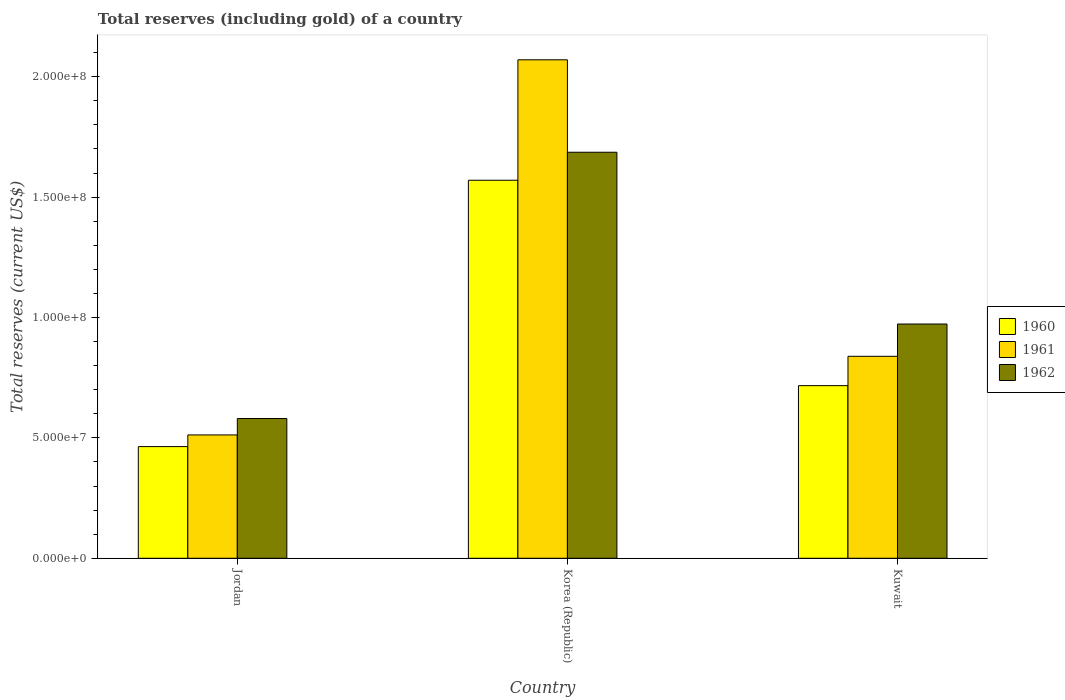How many different coloured bars are there?
Offer a terse response. 3. Are the number of bars per tick equal to the number of legend labels?
Your answer should be compact. Yes. How many bars are there on the 3rd tick from the left?
Offer a terse response. 3. What is the label of the 1st group of bars from the left?
Give a very brief answer. Jordan. What is the total reserves (including gold) in 1962 in Kuwait?
Your answer should be very brief. 9.73e+07. Across all countries, what is the maximum total reserves (including gold) in 1960?
Keep it short and to the point. 1.57e+08. Across all countries, what is the minimum total reserves (including gold) in 1962?
Your answer should be compact. 5.80e+07. In which country was the total reserves (including gold) in 1961 maximum?
Provide a short and direct response. Korea (Republic). In which country was the total reserves (including gold) in 1960 minimum?
Make the answer very short. Jordan. What is the total total reserves (including gold) in 1962 in the graph?
Your answer should be compact. 3.24e+08. What is the difference between the total reserves (including gold) in 1962 in Jordan and that in Korea (Republic)?
Offer a very short reply. -1.11e+08. What is the difference between the total reserves (including gold) in 1961 in Kuwait and the total reserves (including gold) in 1960 in Jordan?
Make the answer very short. 3.75e+07. What is the average total reserves (including gold) in 1962 per country?
Your answer should be very brief. 1.08e+08. What is the difference between the total reserves (including gold) of/in 1962 and total reserves (including gold) of/in 1961 in Korea (Republic)?
Your answer should be very brief. -3.84e+07. What is the ratio of the total reserves (including gold) in 1962 in Korea (Republic) to that in Kuwait?
Ensure brevity in your answer.  1.73. Is the difference between the total reserves (including gold) in 1962 in Jordan and Korea (Republic) greater than the difference between the total reserves (including gold) in 1961 in Jordan and Korea (Republic)?
Provide a short and direct response. Yes. What is the difference between the highest and the second highest total reserves (including gold) in 1961?
Your answer should be compact. -1.23e+08. What is the difference between the highest and the lowest total reserves (including gold) in 1961?
Make the answer very short. 1.56e+08. In how many countries, is the total reserves (including gold) in 1962 greater than the average total reserves (including gold) in 1962 taken over all countries?
Provide a succinct answer. 1. How many bars are there?
Provide a succinct answer. 9. What is the difference between two consecutive major ticks on the Y-axis?
Your response must be concise. 5.00e+07. Are the values on the major ticks of Y-axis written in scientific E-notation?
Keep it short and to the point. Yes. Does the graph contain any zero values?
Your response must be concise. No. Where does the legend appear in the graph?
Offer a terse response. Center right. How many legend labels are there?
Offer a terse response. 3. What is the title of the graph?
Ensure brevity in your answer.  Total reserves (including gold) of a country. Does "1989" appear as one of the legend labels in the graph?
Offer a terse response. No. What is the label or title of the Y-axis?
Keep it short and to the point. Total reserves (current US$). What is the Total reserves (current US$) of 1960 in Jordan?
Ensure brevity in your answer.  4.64e+07. What is the Total reserves (current US$) of 1961 in Jordan?
Provide a succinct answer. 5.12e+07. What is the Total reserves (current US$) of 1962 in Jordan?
Ensure brevity in your answer.  5.80e+07. What is the Total reserves (current US$) in 1960 in Korea (Republic)?
Offer a very short reply. 1.57e+08. What is the Total reserves (current US$) of 1961 in Korea (Republic)?
Your answer should be very brief. 2.07e+08. What is the Total reserves (current US$) in 1962 in Korea (Republic)?
Your response must be concise. 1.69e+08. What is the Total reserves (current US$) of 1960 in Kuwait?
Give a very brief answer. 7.17e+07. What is the Total reserves (current US$) in 1961 in Kuwait?
Ensure brevity in your answer.  8.39e+07. What is the Total reserves (current US$) of 1962 in Kuwait?
Give a very brief answer. 9.73e+07. Across all countries, what is the maximum Total reserves (current US$) in 1960?
Offer a terse response. 1.57e+08. Across all countries, what is the maximum Total reserves (current US$) of 1961?
Your answer should be very brief. 2.07e+08. Across all countries, what is the maximum Total reserves (current US$) in 1962?
Give a very brief answer. 1.69e+08. Across all countries, what is the minimum Total reserves (current US$) of 1960?
Make the answer very short. 4.64e+07. Across all countries, what is the minimum Total reserves (current US$) in 1961?
Your answer should be compact. 5.12e+07. Across all countries, what is the minimum Total reserves (current US$) of 1962?
Offer a very short reply. 5.80e+07. What is the total Total reserves (current US$) in 1960 in the graph?
Provide a short and direct response. 2.75e+08. What is the total Total reserves (current US$) of 1961 in the graph?
Keep it short and to the point. 3.42e+08. What is the total Total reserves (current US$) of 1962 in the graph?
Your answer should be compact. 3.24e+08. What is the difference between the Total reserves (current US$) in 1960 in Jordan and that in Korea (Republic)?
Ensure brevity in your answer.  -1.11e+08. What is the difference between the Total reserves (current US$) in 1961 in Jordan and that in Korea (Republic)?
Make the answer very short. -1.56e+08. What is the difference between the Total reserves (current US$) in 1962 in Jordan and that in Korea (Republic)?
Make the answer very short. -1.11e+08. What is the difference between the Total reserves (current US$) in 1960 in Jordan and that in Kuwait?
Give a very brief answer. -2.53e+07. What is the difference between the Total reserves (current US$) in 1961 in Jordan and that in Kuwait?
Keep it short and to the point. -3.27e+07. What is the difference between the Total reserves (current US$) in 1962 in Jordan and that in Kuwait?
Your answer should be compact. -3.92e+07. What is the difference between the Total reserves (current US$) in 1960 in Korea (Republic) and that in Kuwait?
Offer a terse response. 8.53e+07. What is the difference between the Total reserves (current US$) in 1961 in Korea (Republic) and that in Kuwait?
Your response must be concise. 1.23e+08. What is the difference between the Total reserves (current US$) of 1962 in Korea (Republic) and that in Kuwait?
Your answer should be compact. 7.14e+07. What is the difference between the Total reserves (current US$) in 1960 in Jordan and the Total reserves (current US$) in 1961 in Korea (Republic)?
Keep it short and to the point. -1.61e+08. What is the difference between the Total reserves (current US$) in 1960 in Jordan and the Total reserves (current US$) in 1962 in Korea (Republic)?
Your answer should be very brief. -1.22e+08. What is the difference between the Total reserves (current US$) of 1961 in Jordan and the Total reserves (current US$) of 1962 in Korea (Republic)?
Offer a terse response. -1.17e+08. What is the difference between the Total reserves (current US$) of 1960 in Jordan and the Total reserves (current US$) of 1961 in Kuwait?
Your response must be concise. -3.75e+07. What is the difference between the Total reserves (current US$) of 1960 in Jordan and the Total reserves (current US$) of 1962 in Kuwait?
Provide a succinct answer. -5.09e+07. What is the difference between the Total reserves (current US$) of 1961 in Jordan and the Total reserves (current US$) of 1962 in Kuwait?
Your response must be concise. -4.61e+07. What is the difference between the Total reserves (current US$) in 1960 in Korea (Republic) and the Total reserves (current US$) in 1961 in Kuwait?
Your response must be concise. 7.31e+07. What is the difference between the Total reserves (current US$) in 1960 in Korea (Republic) and the Total reserves (current US$) in 1962 in Kuwait?
Provide a short and direct response. 5.97e+07. What is the difference between the Total reserves (current US$) of 1961 in Korea (Republic) and the Total reserves (current US$) of 1962 in Kuwait?
Give a very brief answer. 1.10e+08. What is the average Total reserves (current US$) of 1960 per country?
Provide a succinct answer. 9.17e+07. What is the average Total reserves (current US$) of 1961 per country?
Your answer should be compact. 1.14e+08. What is the average Total reserves (current US$) of 1962 per country?
Your answer should be very brief. 1.08e+08. What is the difference between the Total reserves (current US$) of 1960 and Total reserves (current US$) of 1961 in Jordan?
Provide a short and direct response. -4.85e+06. What is the difference between the Total reserves (current US$) of 1960 and Total reserves (current US$) of 1962 in Jordan?
Make the answer very short. -1.17e+07. What is the difference between the Total reserves (current US$) of 1961 and Total reserves (current US$) of 1962 in Jordan?
Provide a succinct answer. -6.82e+06. What is the difference between the Total reserves (current US$) of 1960 and Total reserves (current US$) of 1961 in Korea (Republic)?
Give a very brief answer. -5.00e+07. What is the difference between the Total reserves (current US$) of 1960 and Total reserves (current US$) of 1962 in Korea (Republic)?
Keep it short and to the point. -1.16e+07. What is the difference between the Total reserves (current US$) of 1961 and Total reserves (current US$) of 1962 in Korea (Republic)?
Provide a succinct answer. 3.84e+07. What is the difference between the Total reserves (current US$) in 1960 and Total reserves (current US$) in 1961 in Kuwait?
Offer a terse response. -1.22e+07. What is the difference between the Total reserves (current US$) in 1960 and Total reserves (current US$) in 1962 in Kuwait?
Make the answer very short. -2.56e+07. What is the difference between the Total reserves (current US$) of 1961 and Total reserves (current US$) of 1962 in Kuwait?
Make the answer very short. -1.34e+07. What is the ratio of the Total reserves (current US$) of 1960 in Jordan to that in Korea (Republic)?
Ensure brevity in your answer.  0.3. What is the ratio of the Total reserves (current US$) of 1961 in Jordan to that in Korea (Republic)?
Your answer should be very brief. 0.25. What is the ratio of the Total reserves (current US$) in 1962 in Jordan to that in Korea (Republic)?
Your response must be concise. 0.34. What is the ratio of the Total reserves (current US$) in 1960 in Jordan to that in Kuwait?
Your answer should be compact. 0.65. What is the ratio of the Total reserves (current US$) in 1961 in Jordan to that in Kuwait?
Provide a succinct answer. 0.61. What is the ratio of the Total reserves (current US$) of 1962 in Jordan to that in Kuwait?
Give a very brief answer. 0.6. What is the ratio of the Total reserves (current US$) of 1960 in Korea (Republic) to that in Kuwait?
Keep it short and to the point. 2.19. What is the ratio of the Total reserves (current US$) in 1961 in Korea (Republic) to that in Kuwait?
Provide a succinct answer. 2.47. What is the ratio of the Total reserves (current US$) in 1962 in Korea (Republic) to that in Kuwait?
Keep it short and to the point. 1.73. What is the difference between the highest and the second highest Total reserves (current US$) in 1960?
Provide a succinct answer. 8.53e+07. What is the difference between the highest and the second highest Total reserves (current US$) in 1961?
Offer a very short reply. 1.23e+08. What is the difference between the highest and the second highest Total reserves (current US$) in 1962?
Provide a succinct answer. 7.14e+07. What is the difference between the highest and the lowest Total reserves (current US$) in 1960?
Ensure brevity in your answer.  1.11e+08. What is the difference between the highest and the lowest Total reserves (current US$) in 1961?
Your answer should be compact. 1.56e+08. What is the difference between the highest and the lowest Total reserves (current US$) in 1962?
Offer a terse response. 1.11e+08. 